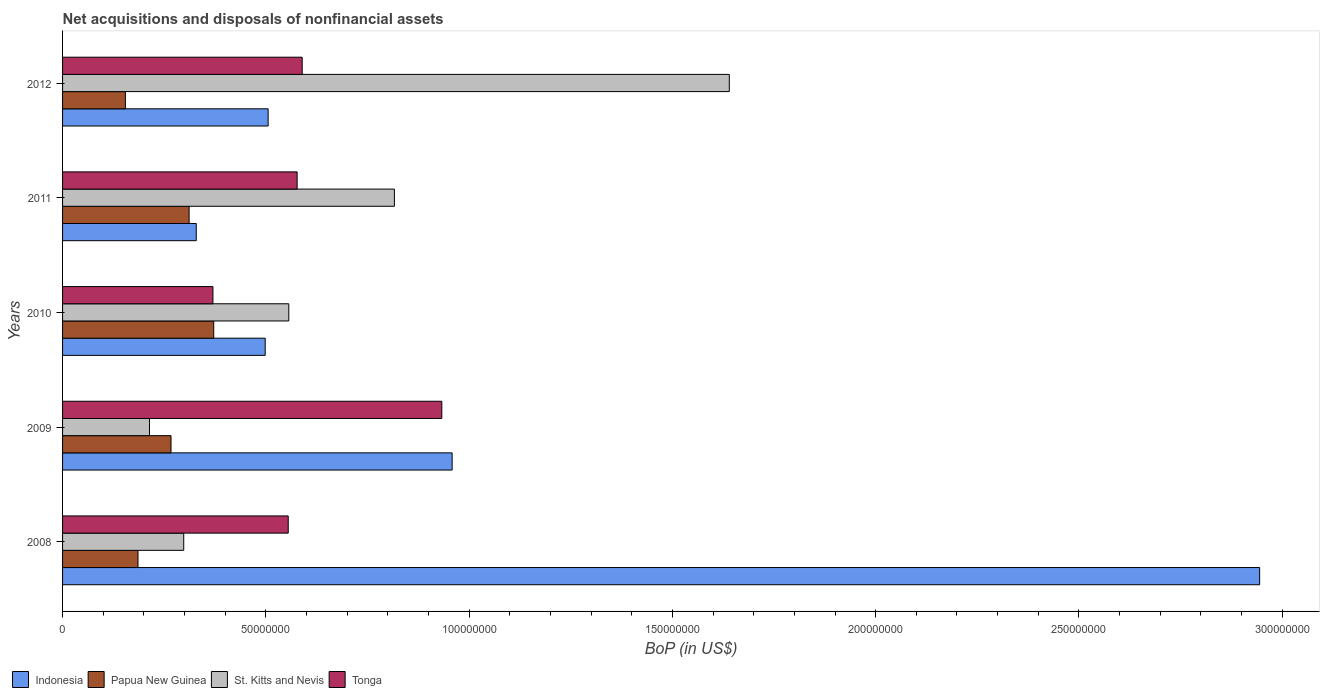Are the number of bars per tick equal to the number of legend labels?
Offer a very short reply. Yes. How many bars are there on the 2nd tick from the bottom?
Provide a short and direct response. 4. In how many cases, is the number of bars for a given year not equal to the number of legend labels?
Your answer should be very brief. 0. What is the Balance of Payments in Papua New Guinea in 2011?
Give a very brief answer. 3.11e+07. Across all years, what is the maximum Balance of Payments in St. Kitts and Nevis?
Make the answer very short. 1.64e+08. Across all years, what is the minimum Balance of Payments in Indonesia?
Keep it short and to the point. 3.29e+07. In which year was the Balance of Payments in Indonesia maximum?
Give a very brief answer. 2008. What is the total Balance of Payments in Indonesia in the graph?
Your answer should be compact. 5.24e+08. What is the difference between the Balance of Payments in St. Kitts and Nevis in 2010 and that in 2012?
Offer a terse response. -1.08e+08. What is the difference between the Balance of Payments in Papua New Guinea in 2010 and the Balance of Payments in Indonesia in 2008?
Make the answer very short. -2.57e+08. What is the average Balance of Payments in St. Kitts and Nevis per year?
Your answer should be very brief. 7.05e+07. In the year 2011, what is the difference between the Balance of Payments in Tonga and Balance of Payments in Papua New Guinea?
Offer a terse response. 2.66e+07. What is the ratio of the Balance of Payments in Tonga in 2009 to that in 2011?
Make the answer very short. 1.62. Is the Balance of Payments in St. Kitts and Nevis in 2008 less than that in 2010?
Provide a short and direct response. Yes. Is the difference between the Balance of Payments in Tonga in 2008 and 2009 greater than the difference between the Balance of Payments in Papua New Guinea in 2008 and 2009?
Ensure brevity in your answer.  No. What is the difference between the highest and the second highest Balance of Payments in Indonesia?
Offer a terse response. 1.99e+08. What is the difference between the highest and the lowest Balance of Payments in St. Kitts and Nevis?
Keep it short and to the point. 1.43e+08. In how many years, is the Balance of Payments in Papua New Guinea greater than the average Balance of Payments in Papua New Guinea taken over all years?
Ensure brevity in your answer.  3. Is the sum of the Balance of Payments in Papua New Guinea in 2011 and 2012 greater than the maximum Balance of Payments in St. Kitts and Nevis across all years?
Ensure brevity in your answer.  No. Is it the case that in every year, the sum of the Balance of Payments in Tonga and Balance of Payments in St. Kitts and Nevis is greater than the sum of Balance of Payments in Papua New Guinea and Balance of Payments in Indonesia?
Offer a terse response. Yes. What does the 4th bar from the top in 2012 represents?
Provide a succinct answer. Indonesia. What does the 3rd bar from the bottom in 2012 represents?
Make the answer very short. St. Kitts and Nevis. How many bars are there?
Your answer should be very brief. 20. How many years are there in the graph?
Your answer should be compact. 5. What is the difference between two consecutive major ticks on the X-axis?
Keep it short and to the point. 5.00e+07. Does the graph contain any zero values?
Provide a short and direct response. No. Does the graph contain grids?
Provide a succinct answer. No. Where does the legend appear in the graph?
Ensure brevity in your answer.  Bottom left. How are the legend labels stacked?
Offer a terse response. Horizontal. What is the title of the graph?
Provide a short and direct response. Net acquisitions and disposals of nonfinancial assets. Does "Marshall Islands" appear as one of the legend labels in the graph?
Ensure brevity in your answer.  No. What is the label or title of the X-axis?
Your answer should be very brief. BoP (in US$). What is the BoP (in US$) of Indonesia in 2008?
Offer a very short reply. 2.94e+08. What is the BoP (in US$) in Papua New Guinea in 2008?
Give a very brief answer. 1.86e+07. What is the BoP (in US$) in St. Kitts and Nevis in 2008?
Offer a terse response. 2.98e+07. What is the BoP (in US$) in Tonga in 2008?
Ensure brevity in your answer.  5.55e+07. What is the BoP (in US$) of Indonesia in 2009?
Provide a short and direct response. 9.58e+07. What is the BoP (in US$) in Papua New Guinea in 2009?
Offer a very short reply. 2.67e+07. What is the BoP (in US$) in St. Kitts and Nevis in 2009?
Your answer should be compact. 2.14e+07. What is the BoP (in US$) in Tonga in 2009?
Make the answer very short. 9.33e+07. What is the BoP (in US$) in Indonesia in 2010?
Offer a very short reply. 4.98e+07. What is the BoP (in US$) of Papua New Guinea in 2010?
Your answer should be very brief. 3.72e+07. What is the BoP (in US$) of St. Kitts and Nevis in 2010?
Offer a terse response. 5.56e+07. What is the BoP (in US$) in Tonga in 2010?
Your answer should be very brief. 3.70e+07. What is the BoP (in US$) of Indonesia in 2011?
Offer a terse response. 3.29e+07. What is the BoP (in US$) of Papua New Guinea in 2011?
Ensure brevity in your answer.  3.11e+07. What is the BoP (in US$) of St. Kitts and Nevis in 2011?
Make the answer very short. 8.16e+07. What is the BoP (in US$) in Tonga in 2011?
Keep it short and to the point. 5.77e+07. What is the BoP (in US$) in Indonesia in 2012?
Offer a terse response. 5.06e+07. What is the BoP (in US$) in Papua New Guinea in 2012?
Provide a succinct answer. 1.55e+07. What is the BoP (in US$) of St. Kitts and Nevis in 2012?
Provide a short and direct response. 1.64e+08. What is the BoP (in US$) in Tonga in 2012?
Offer a terse response. 5.89e+07. Across all years, what is the maximum BoP (in US$) in Indonesia?
Provide a short and direct response. 2.94e+08. Across all years, what is the maximum BoP (in US$) in Papua New Guinea?
Keep it short and to the point. 3.72e+07. Across all years, what is the maximum BoP (in US$) of St. Kitts and Nevis?
Your answer should be very brief. 1.64e+08. Across all years, what is the maximum BoP (in US$) in Tonga?
Your answer should be very brief. 9.33e+07. Across all years, what is the minimum BoP (in US$) in Indonesia?
Give a very brief answer. 3.29e+07. Across all years, what is the minimum BoP (in US$) of Papua New Guinea?
Make the answer very short. 1.55e+07. Across all years, what is the minimum BoP (in US$) in St. Kitts and Nevis?
Make the answer very short. 2.14e+07. Across all years, what is the minimum BoP (in US$) in Tonga?
Your answer should be very brief. 3.70e+07. What is the total BoP (in US$) of Indonesia in the graph?
Provide a short and direct response. 5.24e+08. What is the total BoP (in US$) in Papua New Guinea in the graph?
Provide a succinct answer. 1.29e+08. What is the total BoP (in US$) of St. Kitts and Nevis in the graph?
Give a very brief answer. 3.52e+08. What is the total BoP (in US$) of Tonga in the graph?
Offer a terse response. 3.02e+08. What is the difference between the BoP (in US$) in Indonesia in 2008 and that in 2009?
Your answer should be very brief. 1.99e+08. What is the difference between the BoP (in US$) of Papua New Guinea in 2008 and that in 2009?
Ensure brevity in your answer.  -8.12e+06. What is the difference between the BoP (in US$) of St. Kitts and Nevis in 2008 and that in 2009?
Provide a succinct answer. 8.42e+06. What is the difference between the BoP (in US$) in Tonga in 2008 and that in 2009?
Give a very brief answer. -3.78e+07. What is the difference between the BoP (in US$) in Indonesia in 2008 and that in 2010?
Provide a short and direct response. 2.45e+08. What is the difference between the BoP (in US$) in Papua New Guinea in 2008 and that in 2010?
Give a very brief answer. -1.86e+07. What is the difference between the BoP (in US$) of St. Kitts and Nevis in 2008 and that in 2010?
Make the answer very short. -2.58e+07. What is the difference between the BoP (in US$) of Tonga in 2008 and that in 2010?
Offer a very short reply. 1.85e+07. What is the difference between the BoP (in US$) of Indonesia in 2008 and that in 2011?
Make the answer very short. 2.62e+08. What is the difference between the BoP (in US$) in Papua New Guinea in 2008 and that in 2011?
Ensure brevity in your answer.  -1.26e+07. What is the difference between the BoP (in US$) in St. Kitts and Nevis in 2008 and that in 2011?
Your answer should be compact. -5.18e+07. What is the difference between the BoP (in US$) in Tonga in 2008 and that in 2011?
Offer a very short reply. -2.19e+06. What is the difference between the BoP (in US$) in Indonesia in 2008 and that in 2012?
Keep it short and to the point. 2.44e+08. What is the difference between the BoP (in US$) of Papua New Guinea in 2008 and that in 2012?
Keep it short and to the point. 3.10e+06. What is the difference between the BoP (in US$) of St. Kitts and Nevis in 2008 and that in 2012?
Make the answer very short. -1.34e+08. What is the difference between the BoP (in US$) in Tonga in 2008 and that in 2012?
Your response must be concise. -3.43e+06. What is the difference between the BoP (in US$) in Indonesia in 2009 and that in 2010?
Give a very brief answer. 4.60e+07. What is the difference between the BoP (in US$) of Papua New Guinea in 2009 and that in 2010?
Give a very brief answer. -1.05e+07. What is the difference between the BoP (in US$) in St. Kitts and Nevis in 2009 and that in 2010?
Give a very brief answer. -3.43e+07. What is the difference between the BoP (in US$) of Tonga in 2009 and that in 2010?
Offer a very short reply. 5.63e+07. What is the difference between the BoP (in US$) in Indonesia in 2009 and that in 2011?
Offer a very short reply. 6.29e+07. What is the difference between the BoP (in US$) in Papua New Guinea in 2009 and that in 2011?
Provide a succinct answer. -4.45e+06. What is the difference between the BoP (in US$) of St. Kitts and Nevis in 2009 and that in 2011?
Keep it short and to the point. -6.02e+07. What is the difference between the BoP (in US$) of Tonga in 2009 and that in 2011?
Keep it short and to the point. 3.56e+07. What is the difference between the BoP (in US$) in Indonesia in 2009 and that in 2012?
Your answer should be compact. 4.53e+07. What is the difference between the BoP (in US$) in Papua New Guinea in 2009 and that in 2012?
Your response must be concise. 1.12e+07. What is the difference between the BoP (in US$) of St. Kitts and Nevis in 2009 and that in 2012?
Ensure brevity in your answer.  -1.43e+08. What is the difference between the BoP (in US$) of Tonga in 2009 and that in 2012?
Provide a short and direct response. 3.43e+07. What is the difference between the BoP (in US$) in Indonesia in 2010 and that in 2011?
Make the answer very short. 1.70e+07. What is the difference between the BoP (in US$) of Papua New Guinea in 2010 and that in 2011?
Keep it short and to the point. 6.05e+06. What is the difference between the BoP (in US$) in St. Kitts and Nevis in 2010 and that in 2011?
Give a very brief answer. -2.60e+07. What is the difference between the BoP (in US$) in Tonga in 2010 and that in 2011?
Your response must be concise. -2.07e+07. What is the difference between the BoP (in US$) in Indonesia in 2010 and that in 2012?
Your answer should be compact. -7.19e+05. What is the difference between the BoP (in US$) of Papua New Guinea in 2010 and that in 2012?
Keep it short and to the point. 2.17e+07. What is the difference between the BoP (in US$) in St. Kitts and Nevis in 2010 and that in 2012?
Provide a succinct answer. -1.08e+08. What is the difference between the BoP (in US$) of Tonga in 2010 and that in 2012?
Your answer should be very brief. -2.20e+07. What is the difference between the BoP (in US$) of Indonesia in 2011 and that in 2012?
Your answer should be compact. -1.77e+07. What is the difference between the BoP (in US$) in Papua New Guinea in 2011 and that in 2012?
Provide a short and direct response. 1.57e+07. What is the difference between the BoP (in US$) of St. Kitts and Nevis in 2011 and that in 2012?
Provide a succinct answer. -8.24e+07. What is the difference between the BoP (in US$) in Tonga in 2011 and that in 2012?
Your response must be concise. -1.24e+06. What is the difference between the BoP (in US$) of Indonesia in 2008 and the BoP (in US$) of Papua New Guinea in 2009?
Provide a short and direct response. 2.68e+08. What is the difference between the BoP (in US$) of Indonesia in 2008 and the BoP (in US$) of St. Kitts and Nevis in 2009?
Your answer should be compact. 2.73e+08. What is the difference between the BoP (in US$) in Indonesia in 2008 and the BoP (in US$) in Tonga in 2009?
Make the answer very short. 2.01e+08. What is the difference between the BoP (in US$) in Papua New Guinea in 2008 and the BoP (in US$) in St. Kitts and Nevis in 2009?
Provide a short and direct response. -2.83e+06. What is the difference between the BoP (in US$) of Papua New Guinea in 2008 and the BoP (in US$) of Tonga in 2009?
Your answer should be very brief. -7.47e+07. What is the difference between the BoP (in US$) in St. Kitts and Nevis in 2008 and the BoP (in US$) in Tonga in 2009?
Offer a very short reply. -6.35e+07. What is the difference between the BoP (in US$) of Indonesia in 2008 and the BoP (in US$) of Papua New Guinea in 2010?
Your answer should be compact. 2.57e+08. What is the difference between the BoP (in US$) of Indonesia in 2008 and the BoP (in US$) of St. Kitts and Nevis in 2010?
Give a very brief answer. 2.39e+08. What is the difference between the BoP (in US$) in Indonesia in 2008 and the BoP (in US$) in Tonga in 2010?
Your response must be concise. 2.57e+08. What is the difference between the BoP (in US$) of Papua New Guinea in 2008 and the BoP (in US$) of St. Kitts and Nevis in 2010?
Your answer should be very brief. -3.71e+07. What is the difference between the BoP (in US$) of Papua New Guinea in 2008 and the BoP (in US$) of Tonga in 2010?
Offer a very short reply. -1.84e+07. What is the difference between the BoP (in US$) in St. Kitts and Nevis in 2008 and the BoP (in US$) in Tonga in 2010?
Provide a short and direct response. -7.18e+06. What is the difference between the BoP (in US$) in Indonesia in 2008 and the BoP (in US$) in Papua New Guinea in 2011?
Provide a short and direct response. 2.63e+08. What is the difference between the BoP (in US$) in Indonesia in 2008 and the BoP (in US$) in St. Kitts and Nevis in 2011?
Offer a very short reply. 2.13e+08. What is the difference between the BoP (in US$) in Indonesia in 2008 and the BoP (in US$) in Tonga in 2011?
Your response must be concise. 2.37e+08. What is the difference between the BoP (in US$) in Papua New Guinea in 2008 and the BoP (in US$) in St. Kitts and Nevis in 2011?
Provide a short and direct response. -6.31e+07. What is the difference between the BoP (in US$) in Papua New Guinea in 2008 and the BoP (in US$) in Tonga in 2011?
Ensure brevity in your answer.  -3.91e+07. What is the difference between the BoP (in US$) of St. Kitts and Nevis in 2008 and the BoP (in US$) of Tonga in 2011?
Ensure brevity in your answer.  -2.79e+07. What is the difference between the BoP (in US$) in Indonesia in 2008 and the BoP (in US$) in Papua New Guinea in 2012?
Your answer should be compact. 2.79e+08. What is the difference between the BoP (in US$) in Indonesia in 2008 and the BoP (in US$) in St. Kitts and Nevis in 2012?
Provide a succinct answer. 1.30e+08. What is the difference between the BoP (in US$) in Indonesia in 2008 and the BoP (in US$) in Tonga in 2012?
Keep it short and to the point. 2.36e+08. What is the difference between the BoP (in US$) in Papua New Guinea in 2008 and the BoP (in US$) in St. Kitts and Nevis in 2012?
Give a very brief answer. -1.45e+08. What is the difference between the BoP (in US$) of Papua New Guinea in 2008 and the BoP (in US$) of Tonga in 2012?
Provide a succinct answer. -4.04e+07. What is the difference between the BoP (in US$) of St. Kitts and Nevis in 2008 and the BoP (in US$) of Tonga in 2012?
Provide a succinct answer. -2.91e+07. What is the difference between the BoP (in US$) of Indonesia in 2009 and the BoP (in US$) of Papua New Guinea in 2010?
Offer a very short reply. 5.86e+07. What is the difference between the BoP (in US$) of Indonesia in 2009 and the BoP (in US$) of St. Kitts and Nevis in 2010?
Your response must be concise. 4.02e+07. What is the difference between the BoP (in US$) in Indonesia in 2009 and the BoP (in US$) in Tonga in 2010?
Provide a short and direct response. 5.88e+07. What is the difference between the BoP (in US$) of Papua New Guinea in 2009 and the BoP (in US$) of St. Kitts and Nevis in 2010?
Your response must be concise. -2.90e+07. What is the difference between the BoP (in US$) in Papua New Guinea in 2009 and the BoP (in US$) in Tonga in 2010?
Your answer should be compact. -1.03e+07. What is the difference between the BoP (in US$) in St. Kitts and Nevis in 2009 and the BoP (in US$) in Tonga in 2010?
Your response must be concise. -1.56e+07. What is the difference between the BoP (in US$) in Indonesia in 2009 and the BoP (in US$) in Papua New Guinea in 2011?
Offer a very short reply. 6.47e+07. What is the difference between the BoP (in US$) of Indonesia in 2009 and the BoP (in US$) of St. Kitts and Nevis in 2011?
Your response must be concise. 1.42e+07. What is the difference between the BoP (in US$) of Indonesia in 2009 and the BoP (in US$) of Tonga in 2011?
Give a very brief answer. 3.81e+07. What is the difference between the BoP (in US$) in Papua New Guinea in 2009 and the BoP (in US$) in St. Kitts and Nevis in 2011?
Your answer should be very brief. -5.49e+07. What is the difference between the BoP (in US$) of Papua New Guinea in 2009 and the BoP (in US$) of Tonga in 2011?
Keep it short and to the point. -3.10e+07. What is the difference between the BoP (in US$) in St. Kitts and Nevis in 2009 and the BoP (in US$) in Tonga in 2011?
Give a very brief answer. -3.63e+07. What is the difference between the BoP (in US$) of Indonesia in 2009 and the BoP (in US$) of Papua New Guinea in 2012?
Give a very brief answer. 8.04e+07. What is the difference between the BoP (in US$) in Indonesia in 2009 and the BoP (in US$) in St. Kitts and Nevis in 2012?
Your response must be concise. -6.82e+07. What is the difference between the BoP (in US$) in Indonesia in 2009 and the BoP (in US$) in Tonga in 2012?
Your answer should be compact. 3.69e+07. What is the difference between the BoP (in US$) in Papua New Guinea in 2009 and the BoP (in US$) in St. Kitts and Nevis in 2012?
Your answer should be very brief. -1.37e+08. What is the difference between the BoP (in US$) in Papua New Guinea in 2009 and the BoP (in US$) in Tonga in 2012?
Keep it short and to the point. -3.23e+07. What is the difference between the BoP (in US$) of St. Kitts and Nevis in 2009 and the BoP (in US$) of Tonga in 2012?
Provide a succinct answer. -3.76e+07. What is the difference between the BoP (in US$) in Indonesia in 2010 and the BoP (in US$) in Papua New Guinea in 2011?
Give a very brief answer. 1.87e+07. What is the difference between the BoP (in US$) of Indonesia in 2010 and the BoP (in US$) of St. Kitts and Nevis in 2011?
Your answer should be compact. -3.18e+07. What is the difference between the BoP (in US$) in Indonesia in 2010 and the BoP (in US$) in Tonga in 2011?
Your answer should be very brief. -7.85e+06. What is the difference between the BoP (in US$) in Papua New Guinea in 2010 and the BoP (in US$) in St. Kitts and Nevis in 2011?
Keep it short and to the point. -4.44e+07. What is the difference between the BoP (in US$) in Papua New Guinea in 2010 and the BoP (in US$) in Tonga in 2011?
Provide a succinct answer. -2.05e+07. What is the difference between the BoP (in US$) in St. Kitts and Nevis in 2010 and the BoP (in US$) in Tonga in 2011?
Provide a succinct answer. -2.05e+06. What is the difference between the BoP (in US$) in Indonesia in 2010 and the BoP (in US$) in Papua New Guinea in 2012?
Offer a terse response. 3.44e+07. What is the difference between the BoP (in US$) in Indonesia in 2010 and the BoP (in US$) in St. Kitts and Nevis in 2012?
Your answer should be very brief. -1.14e+08. What is the difference between the BoP (in US$) in Indonesia in 2010 and the BoP (in US$) in Tonga in 2012?
Provide a short and direct response. -9.10e+06. What is the difference between the BoP (in US$) in Papua New Guinea in 2010 and the BoP (in US$) in St. Kitts and Nevis in 2012?
Ensure brevity in your answer.  -1.27e+08. What is the difference between the BoP (in US$) in Papua New Guinea in 2010 and the BoP (in US$) in Tonga in 2012?
Give a very brief answer. -2.18e+07. What is the difference between the BoP (in US$) of St. Kitts and Nevis in 2010 and the BoP (in US$) of Tonga in 2012?
Your answer should be compact. -3.30e+06. What is the difference between the BoP (in US$) in Indonesia in 2011 and the BoP (in US$) in Papua New Guinea in 2012?
Ensure brevity in your answer.  1.74e+07. What is the difference between the BoP (in US$) of Indonesia in 2011 and the BoP (in US$) of St. Kitts and Nevis in 2012?
Offer a very short reply. -1.31e+08. What is the difference between the BoP (in US$) in Indonesia in 2011 and the BoP (in US$) in Tonga in 2012?
Your response must be concise. -2.61e+07. What is the difference between the BoP (in US$) of Papua New Guinea in 2011 and the BoP (in US$) of St. Kitts and Nevis in 2012?
Your answer should be compact. -1.33e+08. What is the difference between the BoP (in US$) of Papua New Guinea in 2011 and the BoP (in US$) of Tonga in 2012?
Your answer should be compact. -2.78e+07. What is the difference between the BoP (in US$) in St. Kitts and Nevis in 2011 and the BoP (in US$) in Tonga in 2012?
Make the answer very short. 2.27e+07. What is the average BoP (in US$) in Indonesia per year?
Keep it short and to the point. 1.05e+08. What is the average BoP (in US$) in Papua New Guinea per year?
Your answer should be very brief. 2.58e+07. What is the average BoP (in US$) of St. Kitts and Nevis per year?
Offer a very short reply. 7.05e+07. What is the average BoP (in US$) in Tonga per year?
Provide a succinct answer. 6.05e+07. In the year 2008, what is the difference between the BoP (in US$) of Indonesia and BoP (in US$) of Papua New Guinea?
Make the answer very short. 2.76e+08. In the year 2008, what is the difference between the BoP (in US$) of Indonesia and BoP (in US$) of St. Kitts and Nevis?
Give a very brief answer. 2.65e+08. In the year 2008, what is the difference between the BoP (in US$) in Indonesia and BoP (in US$) in Tonga?
Provide a succinct answer. 2.39e+08. In the year 2008, what is the difference between the BoP (in US$) of Papua New Guinea and BoP (in US$) of St. Kitts and Nevis?
Offer a terse response. -1.12e+07. In the year 2008, what is the difference between the BoP (in US$) of Papua New Guinea and BoP (in US$) of Tonga?
Your answer should be compact. -3.70e+07. In the year 2008, what is the difference between the BoP (in US$) of St. Kitts and Nevis and BoP (in US$) of Tonga?
Keep it short and to the point. -2.57e+07. In the year 2009, what is the difference between the BoP (in US$) of Indonesia and BoP (in US$) of Papua New Guinea?
Offer a terse response. 6.91e+07. In the year 2009, what is the difference between the BoP (in US$) in Indonesia and BoP (in US$) in St. Kitts and Nevis?
Make the answer very short. 7.44e+07. In the year 2009, what is the difference between the BoP (in US$) of Indonesia and BoP (in US$) of Tonga?
Your response must be concise. 2.54e+06. In the year 2009, what is the difference between the BoP (in US$) in Papua New Guinea and BoP (in US$) in St. Kitts and Nevis?
Make the answer very short. 5.29e+06. In the year 2009, what is the difference between the BoP (in US$) in Papua New Guinea and BoP (in US$) in Tonga?
Your answer should be compact. -6.66e+07. In the year 2009, what is the difference between the BoP (in US$) of St. Kitts and Nevis and BoP (in US$) of Tonga?
Provide a succinct answer. -7.19e+07. In the year 2010, what is the difference between the BoP (in US$) in Indonesia and BoP (in US$) in Papua New Guinea?
Give a very brief answer. 1.27e+07. In the year 2010, what is the difference between the BoP (in US$) in Indonesia and BoP (in US$) in St. Kitts and Nevis?
Provide a succinct answer. -5.80e+06. In the year 2010, what is the difference between the BoP (in US$) of Indonesia and BoP (in US$) of Tonga?
Ensure brevity in your answer.  1.29e+07. In the year 2010, what is the difference between the BoP (in US$) of Papua New Guinea and BoP (in US$) of St. Kitts and Nevis?
Offer a terse response. -1.85e+07. In the year 2010, what is the difference between the BoP (in US$) of Papua New Guinea and BoP (in US$) of Tonga?
Offer a very short reply. 1.91e+05. In the year 2010, what is the difference between the BoP (in US$) of St. Kitts and Nevis and BoP (in US$) of Tonga?
Keep it short and to the point. 1.87e+07. In the year 2011, what is the difference between the BoP (in US$) of Indonesia and BoP (in US$) of Papua New Guinea?
Make the answer very short. 1.76e+06. In the year 2011, what is the difference between the BoP (in US$) in Indonesia and BoP (in US$) in St. Kitts and Nevis?
Your answer should be compact. -4.87e+07. In the year 2011, what is the difference between the BoP (in US$) of Indonesia and BoP (in US$) of Tonga?
Offer a very short reply. -2.48e+07. In the year 2011, what is the difference between the BoP (in US$) of Papua New Guinea and BoP (in US$) of St. Kitts and Nevis?
Keep it short and to the point. -5.05e+07. In the year 2011, what is the difference between the BoP (in US$) of Papua New Guinea and BoP (in US$) of Tonga?
Your response must be concise. -2.66e+07. In the year 2011, what is the difference between the BoP (in US$) in St. Kitts and Nevis and BoP (in US$) in Tonga?
Offer a very short reply. 2.39e+07. In the year 2012, what is the difference between the BoP (in US$) of Indonesia and BoP (in US$) of Papua New Guinea?
Your response must be concise. 3.51e+07. In the year 2012, what is the difference between the BoP (in US$) in Indonesia and BoP (in US$) in St. Kitts and Nevis?
Your answer should be compact. -1.13e+08. In the year 2012, what is the difference between the BoP (in US$) in Indonesia and BoP (in US$) in Tonga?
Your response must be concise. -8.38e+06. In the year 2012, what is the difference between the BoP (in US$) in Papua New Guinea and BoP (in US$) in St. Kitts and Nevis?
Your response must be concise. -1.49e+08. In the year 2012, what is the difference between the BoP (in US$) in Papua New Guinea and BoP (in US$) in Tonga?
Your answer should be very brief. -4.35e+07. In the year 2012, what is the difference between the BoP (in US$) of St. Kitts and Nevis and BoP (in US$) of Tonga?
Make the answer very short. 1.05e+08. What is the ratio of the BoP (in US$) in Indonesia in 2008 to that in 2009?
Make the answer very short. 3.07. What is the ratio of the BoP (in US$) of Papua New Guinea in 2008 to that in 2009?
Ensure brevity in your answer.  0.7. What is the ratio of the BoP (in US$) of St. Kitts and Nevis in 2008 to that in 2009?
Provide a succinct answer. 1.39. What is the ratio of the BoP (in US$) in Tonga in 2008 to that in 2009?
Your answer should be very brief. 0.6. What is the ratio of the BoP (in US$) of Indonesia in 2008 to that in 2010?
Offer a very short reply. 5.91. What is the ratio of the BoP (in US$) of Papua New Guinea in 2008 to that in 2010?
Make the answer very short. 0.5. What is the ratio of the BoP (in US$) of St. Kitts and Nevis in 2008 to that in 2010?
Your response must be concise. 0.54. What is the ratio of the BoP (in US$) in Tonga in 2008 to that in 2010?
Offer a terse response. 1.5. What is the ratio of the BoP (in US$) in Indonesia in 2008 to that in 2011?
Offer a very short reply. 8.95. What is the ratio of the BoP (in US$) in Papua New Guinea in 2008 to that in 2011?
Your answer should be compact. 0.6. What is the ratio of the BoP (in US$) of St. Kitts and Nevis in 2008 to that in 2011?
Provide a short and direct response. 0.37. What is the ratio of the BoP (in US$) in Tonga in 2008 to that in 2011?
Your response must be concise. 0.96. What is the ratio of the BoP (in US$) in Indonesia in 2008 to that in 2012?
Ensure brevity in your answer.  5.82. What is the ratio of the BoP (in US$) of Papua New Guinea in 2008 to that in 2012?
Your response must be concise. 1.2. What is the ratio of the BoP (in US$) in St. Kitts and Nevis in 2008 to that in 2012?
Keep it short and to the point. 0.18. What is the ratio of the BoP (in US$) in Tonga in 2008 to that in 2012?
Make the answer very short. 0.94. What is the ratio of the BoP (in US$) in Indonesia in 2009 to that in 2010?
Offer a terse response. 1.92. What is the ratio of the BoP (in US$) in Papua New Guinea in 2009 to that in 2010?
Your answer should be compact. 0.72. What is the ratio of the BoP (in US$) in St. Kitts and Nevis in 2009 to that in 2010?
Offer a terse response. 0.38. What is the ratio of the BoP (in US$) of Tonga in 2009 to that in 2010?
Provide a short and direct response. 2.52. What is the ratio of the BoP (in US$) in Indonesia in 2009 to that in 2011?
Keep it short and to the point. 2.91. What is the ratio of the BoP (in US$) of Papua New Guinea in 2009 to that in 2011?
Your answer should be very brief. 0.86. What is the ratio of the BoP (in US$) of St. Kitts and Nevis in 2009 to that in 2011?
Your answer should be very brief. 0.26. What is the ratio of the BoP (in US$) of Tonga in 2009 to that in 2011?
Provide a short and direct response. 1.62. What is the ratio of the BoP (in US$) in Indonesia in 2009 to that in 2012?
Ensure brevity in your answer.  1.9. What is the ratio of the BoP (in US$) of Papua New Guinea in 2009 to that in 2012?
Provide a short and direct response. 1.73. What is the ratio of the BoP (in US$) in St. Kitts and Nevis in 2009 to that in 2012?
Provide a short and direct response. 0.13. What is the ratio of the BoP (in US$) of Tonga in 2009 to that in 2012?
Give a very brief answer. 1.58. What is the ratio of the BoP (in US$) of Indonesia in 2010 to that in 2011?
Make the answer very short. 1.52. What is the ratio of the BoP (in US$) of Papua New Guinea in 2010 to that in 2011?
Ensure brevity in your answer.  1.19. What is the ratio of the BoP (in US$) in St. Kitts and Nevis in 2010 to that in 2011?
Your answer should be very brief. 0.68. What is the ratio of the BoP (in US$) of Tonga in 2010 to that in 2011?
Your answer should be very brief. 0.64. What is the ratio of the BoP (in US$) of Indonesia in 2010 to that in 2012?
Offer a very short reply. 0.99. What is the ratio of the BoP (in US$) in Papua New Guinea in 2010 to that in 2012?
Offer a very short reply. 2.41. What is the ratio of the BoP (in US$) in St. Kitts and Nevis in 2010 to that in 2012?
Make the answer very short. 0.34. What is the ratio of the BoP (in US$) of Tonga in 2010 to that in 2012?
Offer a very short reply. 0.63. What is the ratio of the BoP (in US$) in Indonesia in 2011 to that in 2012?
Your answer should be compact. 0.65. What is the ratio of the BoP (in US$) in Papua New Guinea in 2011 to that in 2012?
Offer a very short reply. 2.01. What is the ratio of the BoP (in US$) of St. Kitts and Nevis in 2011 to that in 2012?
Offer a very short reply. 0.5. What is the ratio of the BoP (in US$) of Tonga in 2011 to that in 2012?
Give a very brief answer. 0.98. What is the difference between the highest and the second highest BoP (in US$) in Indonesia?
Ensure brevity in your answer.  1.99e+08. What is the difference between the highest and the second highest BoP (in US$) of Papua New Guinea?
Provide a succinct answer. 6.05e+06. What is the difference between the highest and the second highest BoP (in US$) of St. Kitts and Nevis?
Your answer should be very brief. 8.24e+07. What is the difference between the highest and the second highest BoP (in US$) in Tonga?
Offer a very short reply. 3.43e+07. What is the difference between the highest and the lowest BoP (in US$) in Indonesia?
Offer a terse response. 2.62e+08. What is the difference between the highest and the lowest BoP (in US$) of Papua New Guinea?
Your response must be concise. 2.17e+07. What is the difference between the highest and the lowest BoP (in US$) of St. Kitts and Nevis?
Ensure brevity in your answer.  1.43e+08. What is the difference between the highest and the lowest BoP (in US$) in Tonga?
Your answer should be very brief. 5.63e+07. 